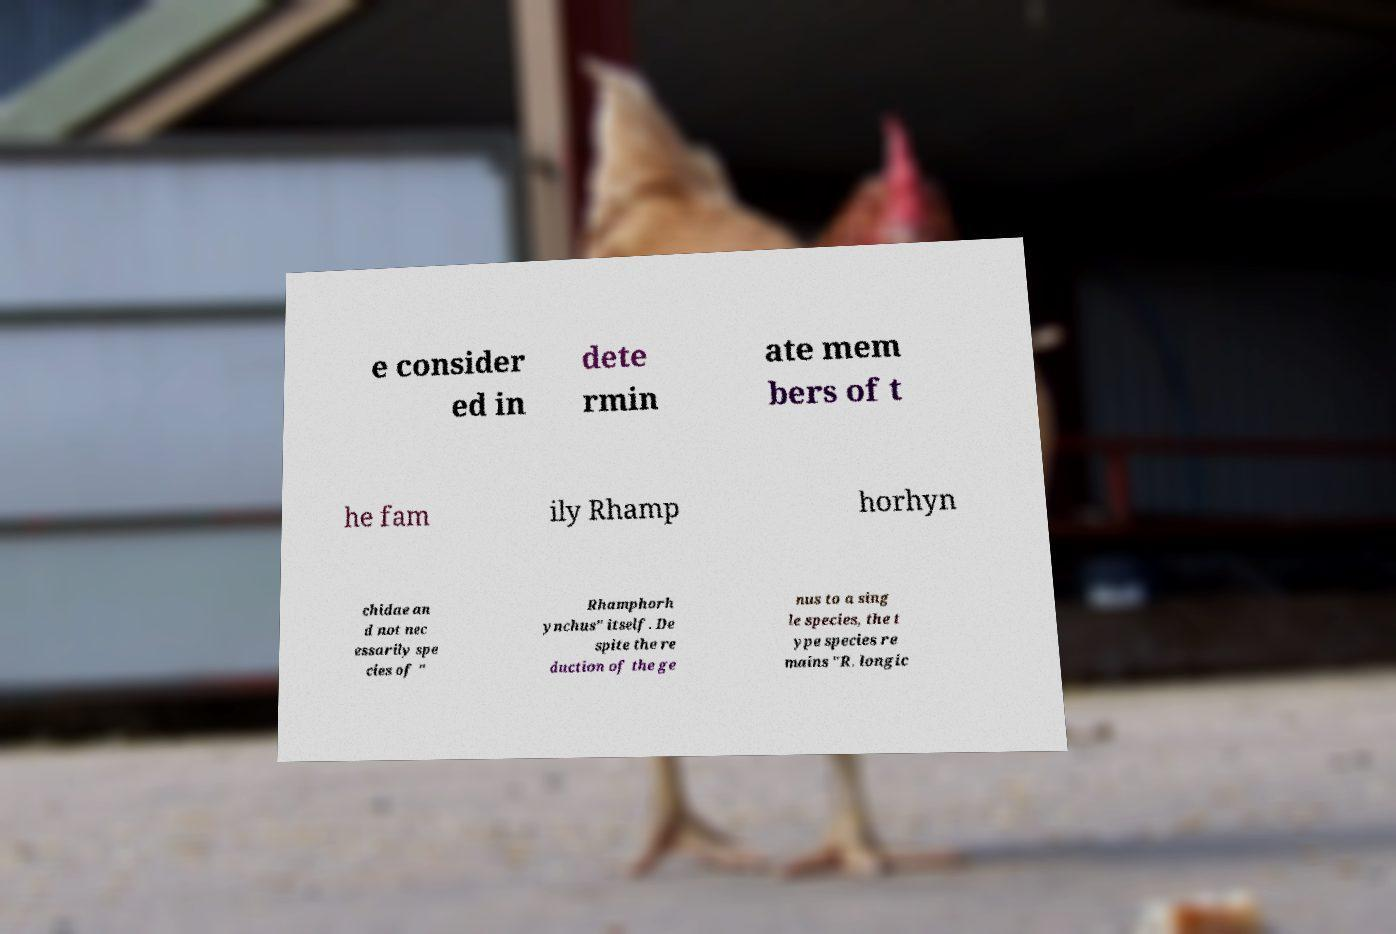What messages or text are displayed in this image? I need them in a readable, typed format. e consider ed in dete rmin ate mem bers of t he fam ily Rhamp horhyn chidae an d not nec essarily spe cies of " Rhamphorh ynchus" itself. De spite the re duction of the ge nus to a sing le species, the t ype species re mains "R. longic 